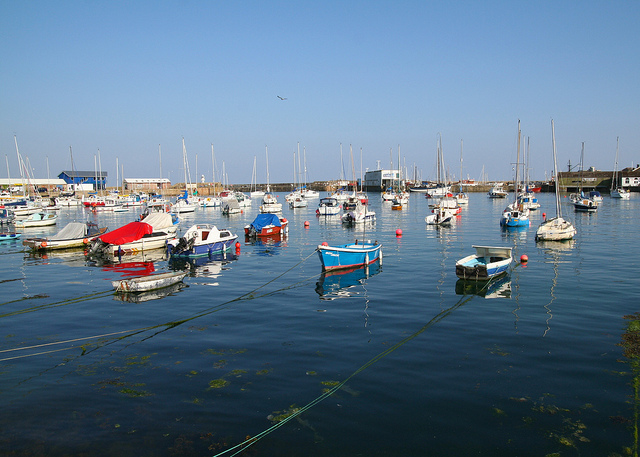What colors are the boats in the foreground of the image? The boats in the foreground have vivid hues, with some appearing in bright red, blue, and white, reflecting their vibrant paint against the backdrop of the water. 